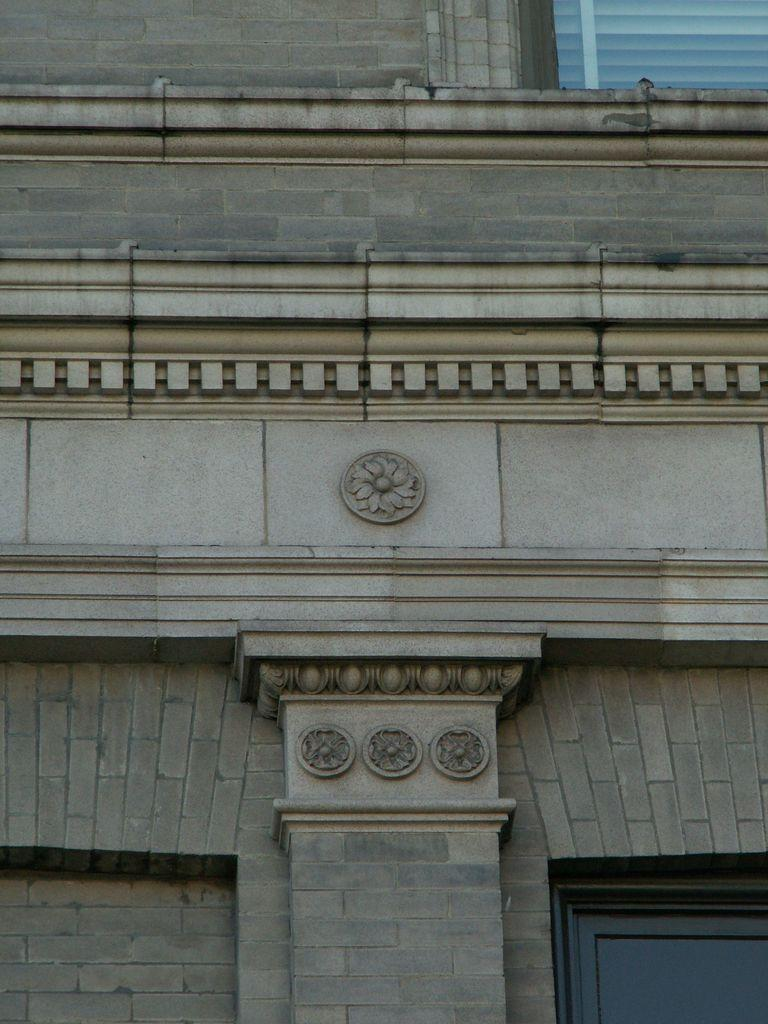What type of structure is visible in the image? There is a building in the image. Can you describe any specific features of the building? There is a window in the image. What is unique about the window? The window has blinds. How many clocks are hanging on the canvas in the image? There is no canvas or clocks present in the image. 